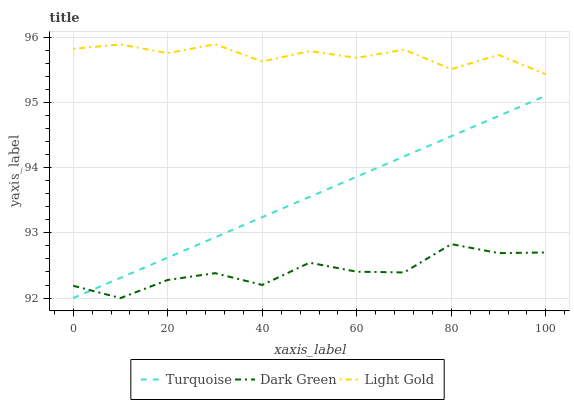Does Dark Green have the minimum area under the curve?
Answer yes or no. Yes. Does Light Gold have the maximum area under the curve?
Answer yes or no. Yes. Does Light Gold have the minimum area under the curve?
Answer yes or no. No. Does Dark Green have the maximum area under the curve?
Answer yes or no. No. Is Turquoise the smoothest?
Answer yes or no. Yes. Is Light Gold the roughest?
Answer yes or no. Yes. Is Dark Green the smoothest?
Answer yes or no. No. Is Dark Green the roughest?
Answer yes or no. No. Does Turquoise have the lowest value?
Answer yes or no. Yes. Does Light Gold have the lowest value?
Answer yes or no. No. Does Light Gold have the highest value?
Answer yes or no. Yes. Does Dark Green have the highest value?
Answer yes or no. No. Is Turquoise less than Light Gold?
Answer yes or no. Yes. Is Light Gold greater than Turquoise?
Answer yes or no. Yes. Does Dark Green intersect Turquoise?
Answer yes or no. Yes. Is Dark Green less than Turquoise?
Answer yes or no. No. Is Dark Green greater than Turquoise?
Answer yes or no. No. Does Turquoise intersect Light Gold?
Answer yes or no. No. 